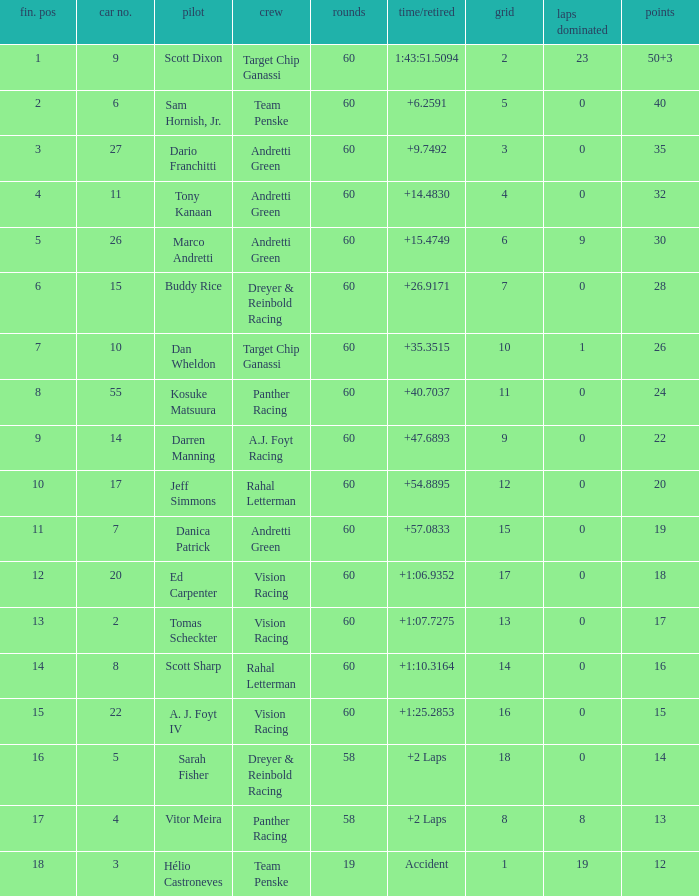Name the team for scott dixon Target Chip Ganassi. 